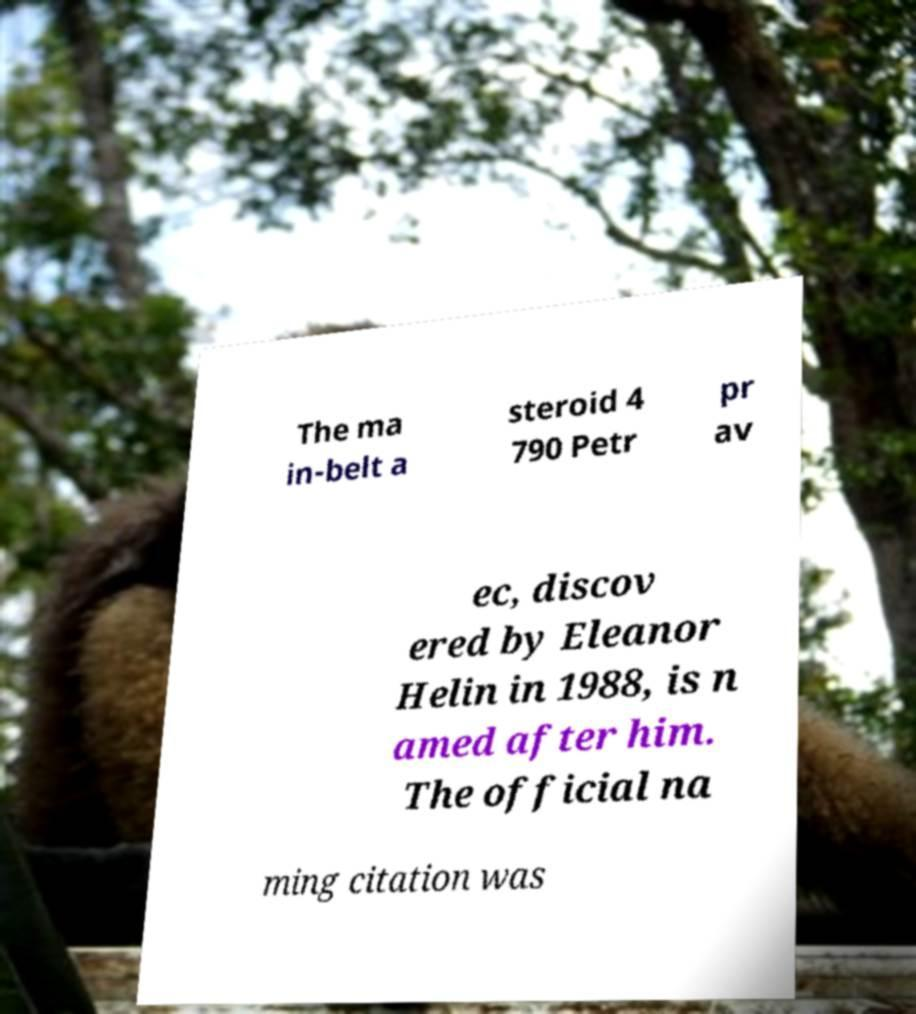Please read and relay the text visible in this image. What does it say? The ma in-belt a steroid 4 790 Petr pr av ec, discov ered by Eleanor Helin in 1988, is n amed after him. The official na ming citation was 